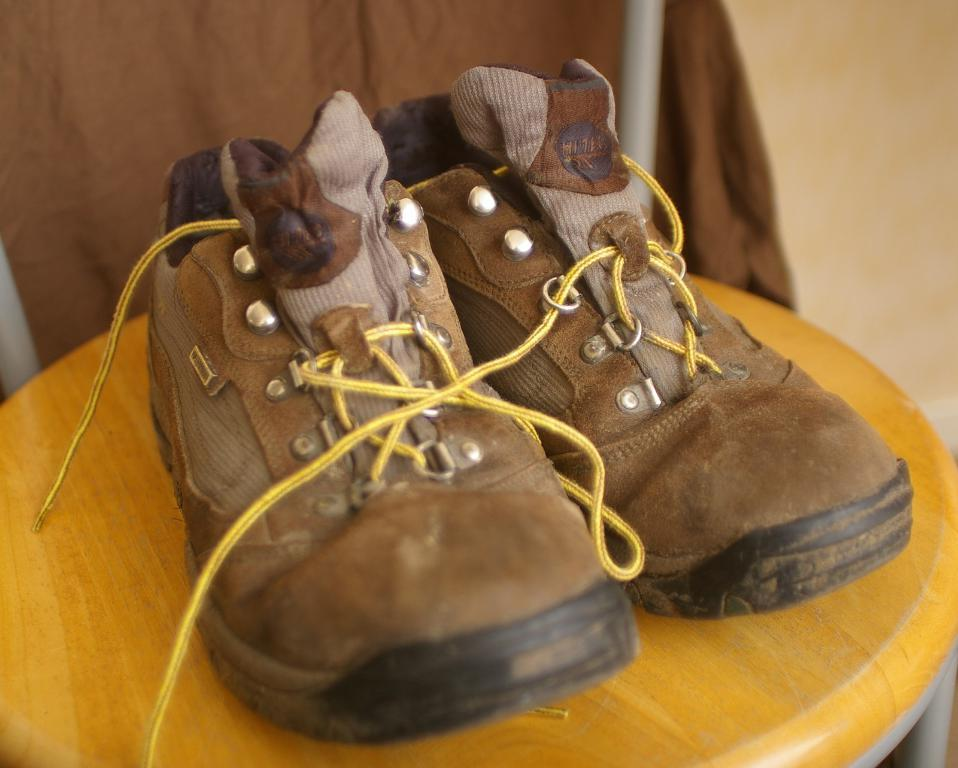What piece of furniture is present in the image? There is a stool in the image. What is placed on the stool? There is a pair of brown color shoes on the stool. What color is the cloth visible in the background? There is a brown color cloth in the background of the image. Where is the oven located in the image? There is no oven present in the image. What mark is visible on the brown color shoes? The provided facts do not mention any specific mark on the shoes, so we cannot answer this question definitively. 